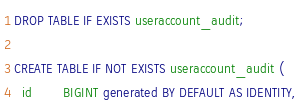<code> <loc_0><loc_0><loc_500><loc_500><_SQL_>DROP TABLE IF EXISTS useraccount_audit;

CREATE TABLE IF NOT EXISTS useraccount_audit (
  id        BIGINT generated BY DEFAULT AS IDENTITY,</code> 